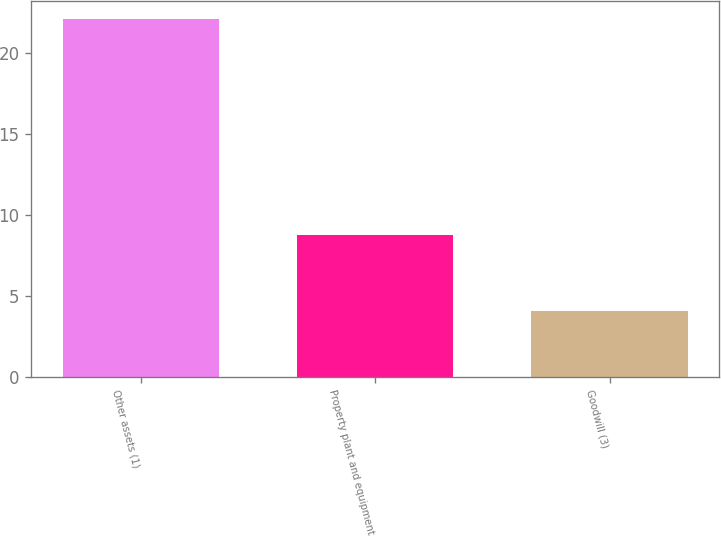<chart> <loc_0><loc_0><loc_500><loc_500><bar_chart><fcel>Other assets (1)<fcel>Property plant and equipment<fcel>Goodwill (3)<nl><fcel>22.1<fcel>8.8<fcel>4.1<nl></chart> 